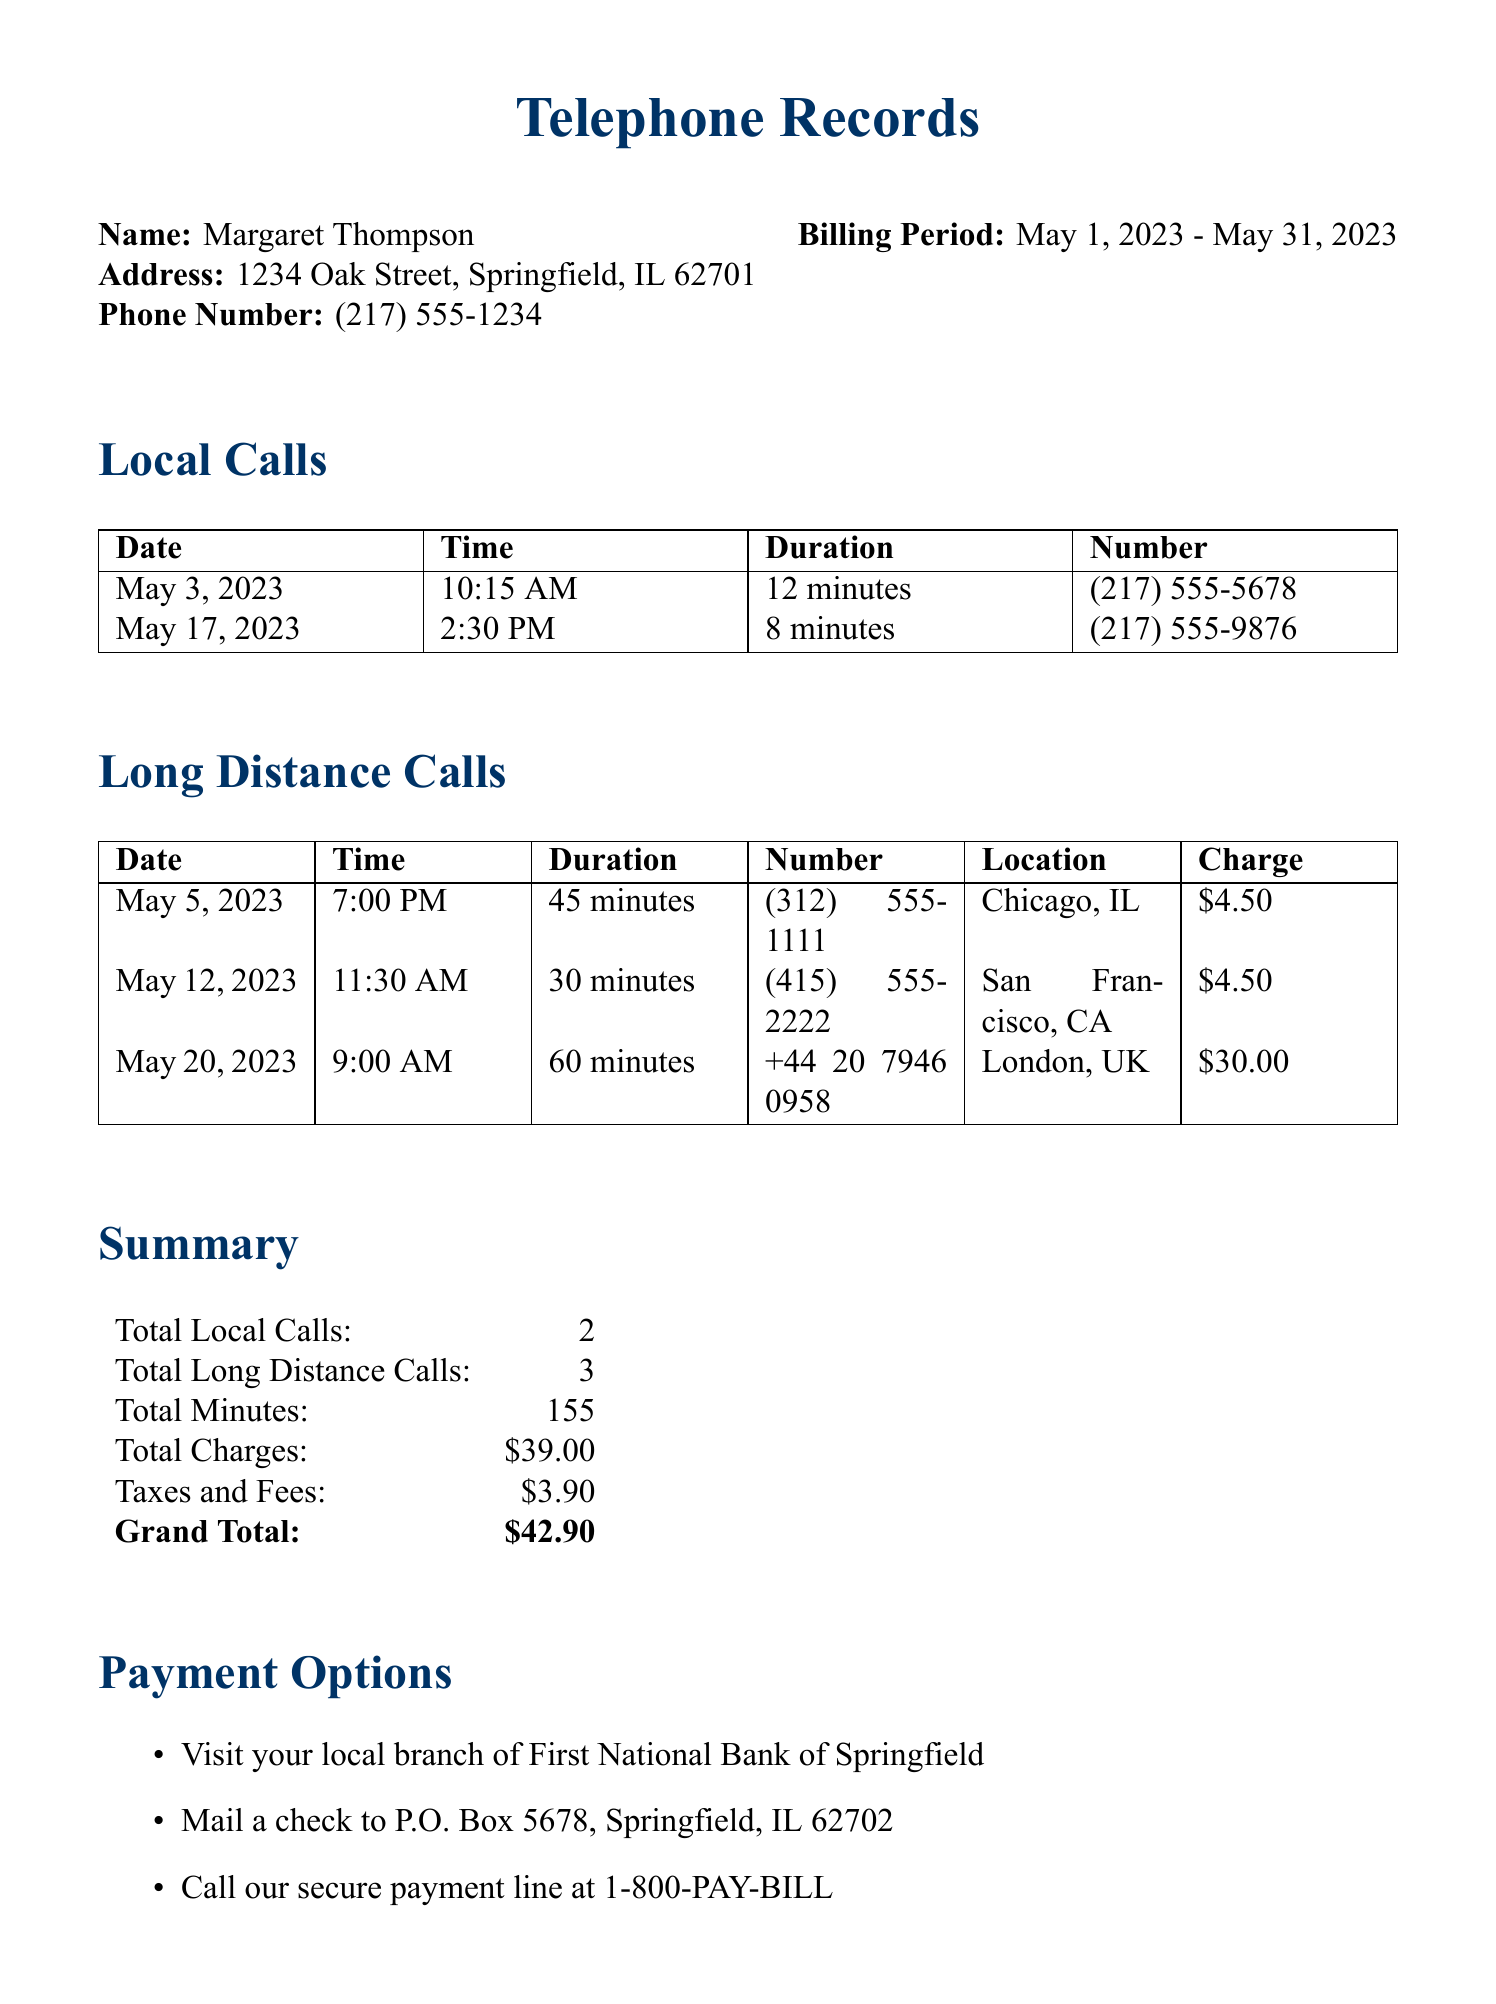What is the total number of local calls? The total number of local calls is listed in the summary section of the document, which states there are 2 local calls.
Answer: 2 What was the charge for the call made to London, UK? The charge for the call made to London, as shown in the long-distance calls section, is \$30.00.
Answer: \$30.00 How long was the longest long-distance call? The longest long-distance call is to London, UK, which lasted for 60 minutes, as noted in the duration column.
Answer: 60 minutes What is the total amount charged for long-distance calls? The total amount charged for long-distance calls is summarized in the summary section, which sums up to \$39.00.
Answer: \$39.00 How many minutes were spent on long-distance calls in total? The total minutes for long-distance calls can be found in the summary section, which states there were 155 minutes in total.
Answer: 155 What is the billing period for these telephone records? The billing period is explicitly stated in the document as May 1, 2023 - May 31, 2023.
Answer: May 1, 2023 - May 31, 2023 What is the total grand amount due? The grand total is provided in the summary section of the document, listed as \$42.90.
Answer: \$42.90 What options are available for making a payment? The payment options are specified in a list, stating three different methods including visiting a local branch, mailing a check, or calling a payment line.
Answer: Visit your local branch, Mail a check, Call our secure payment line 